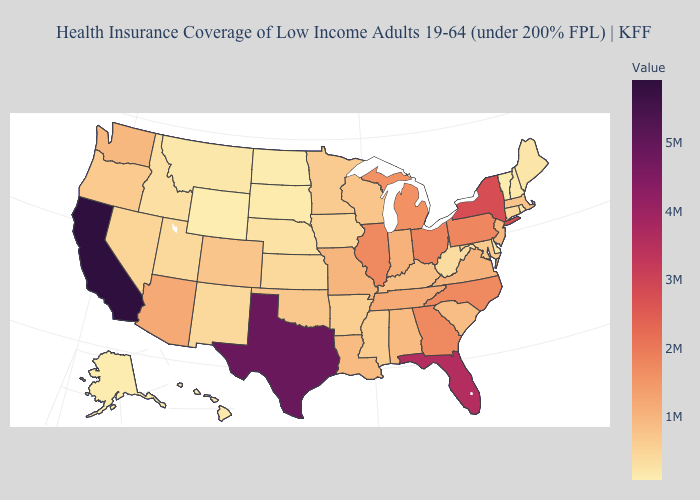Among the states that border Virginia , which have the highest value?
Answer briefly. North Carolina. Among the states that border Texas , does Oklahoma have the highest value?
Concise answer only. No. Which states hav the highest value in the Northeast?
Be succinct. New York. Among the states that border Mississippi , does Louisiana have the lowest value?
Quick response, please. No. Does the map have missing data?
Be succinct. No. Which states have the lowest value in the USA?
Concise answer only. Wyoming. 